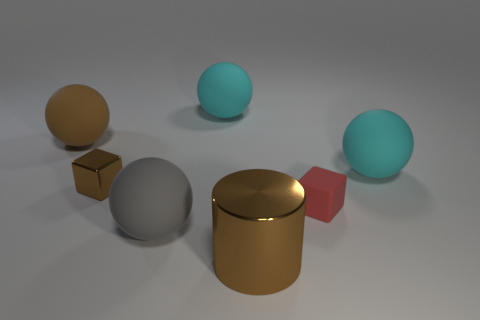Does the metallic block have the same color as the big cylinder?
Offer a very short reply. Yes. There is a big object that is on the left side of the brown metal object behind the big brown metal cylinder; what is it made of?
Ensure brevity in your answer.  Rubber. Is the size of the gray ball the same as the brown cube?
Keep it short and to the point. No. What number of objects are either big brown things to the left of the gray sphere or large cyan metal blocks?
Offer a terse response. 1. The large brown object in front of the cyan rubber sphere that is in front of the brown matte sphere is what shape?
Give a very brief answer. Cylinder. Do the red matte object and the brown metal object behind the small red rubber cube have the same size?
Offer a very short reply. Yes. There is a cyan ball behind the big brown rubber thing; what is it made of?
Your answer should be very brief. Rubber. What number of big matte spheres are behind the tiny red object and in front of the large brown matte sphere?
Provide a succinct answer. 1. What material is the gray object that is the same size as the brown metal cylinder?
Your answer should be compact. Rubber. Is the size of the red rubber thing that is on the right side of the brown cylinder the same as the object in front of the large gray ball?
Provide a succinct answer. No. 